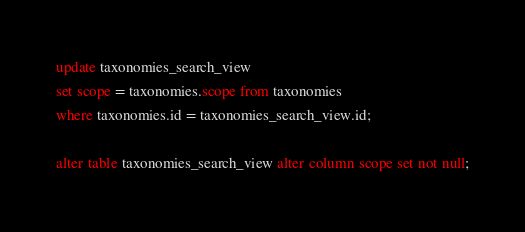<code> <loc_0><loc_0><loc_500><loc_500><_SQL_>
update taxonomies_search_view
set scope = taxonomies.scope from taxonomies
where taxonomies.id = taxonomies_search_view.id;

alter table taxonomies_search_view alter column scope set not null;
</code> 